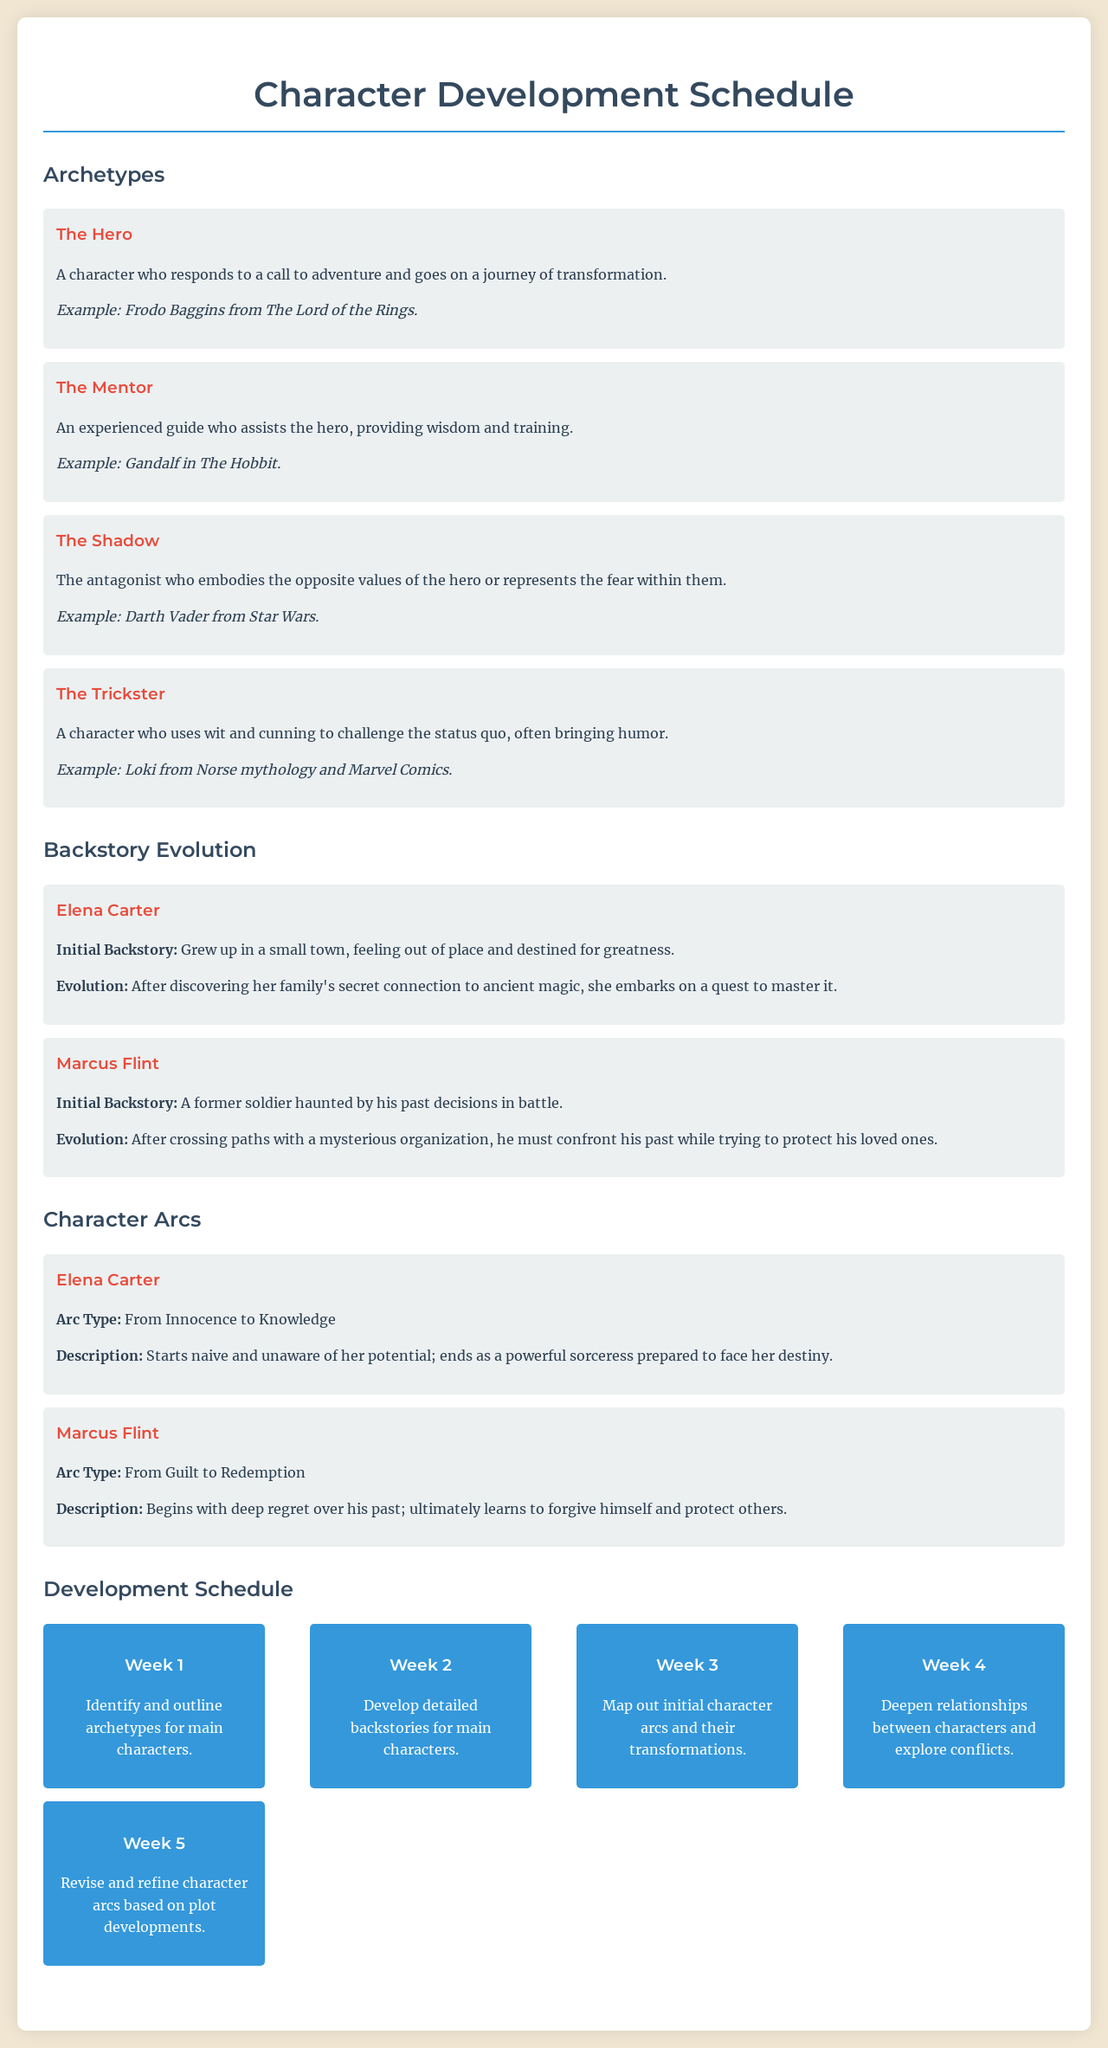What is the primary archetype of Elena Carter? The document lists Elena Carter under specific archetypes, and she is associated with "The Hero."
Answer: The Hero What is Marcus Flint's arc type? The document specifies character arcs and categorizes Marcus Flint as having the arc type "From Guilt to Redemption."
Answer: From Guilt to Redemption During which week should detailed backstories for main characters be developed? The schedule outlines activities for each week, stating that Week 2 focuses on developing backstories.
Answer: Week 2 What example is given for "The Mentor" archetype? The document includes examples for each archetype, mentioning Gandalf in The Hobbit for "The Mentor."
Answer: Gandalf in The Hobbit What is the initial backstory of Elena Carter? The backstory evolution section reveals Elena Carter's initial backstory as having grown up in a small town.
Answer: Grew up in a small town How many weeks are detailed in the development schedule? The schedule consists of five distinct weeks of character development activities.
Answer: Five What aspect of character development is addressed in Week 4? The schedule indicates that Week 4 is focused on exploring relationships and conflicts between characters.
Answer: Relationships and conflicts What is the initial backstory of Marcus Flint? The document outlines Marcus Flint's initial backstory as being haunted by his past decisions in battle.
Answer: Haunted by past decisions in battle What color is used for the titles of sections in the document? The document uses a specific color for heading text, particularly red for section titles.
Answer: Red 